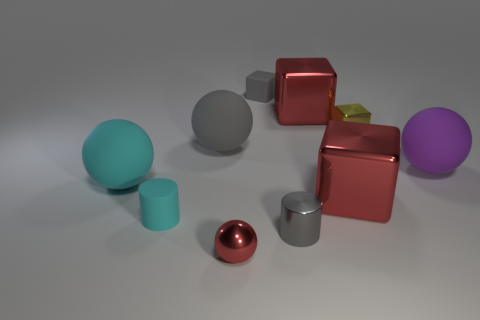Subtract all cylinders. How many objects are left? 8 Add 7 big cyan rubber spheres. How many big cyan rubber spheres exist? 8 Subtract 1 purple balls. How many objects are left? 9 Subtract all large red matte cylinders. Subtract all big purple matte balls. How many objects are left? 9 Add 2 large cyan matte balls. How many large cyan matte balls are left? 3 